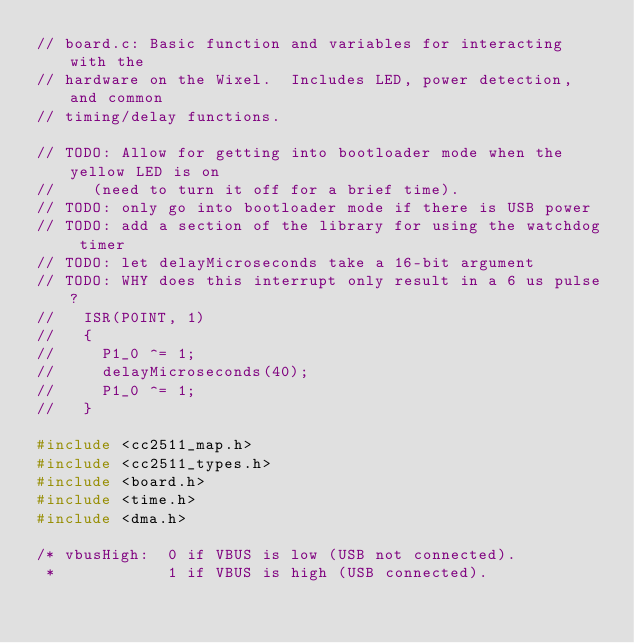<code> <loc_0><loc_0><loc_500><loc_500><_C_>// board.c: Basic function and variables for interacting with the
// hardware on the Wixel.  Includes LED, power detection, and common
// timing/delay functions.

// TODO: Allow for getting into bootloader mode when the yellow LED is on
//    (need to turn it off for a brief time).
// TODO: only go into bootloader mode if there is USB power
// TODO: add a section of the library for using the watchdog timer
// TODO: let delayMicroseconds take a 16-bit argument
// TODO: WHY does this interrupt only result in a 6 us pulse?
//   ISR(P0INT, 1)
//   {
//     P1_0 ^= 1;
//     delayMicroseconds(40);
//     P1_0 ^= 1;
//   }

#include <cc2511_map.h>
#include <cc2511_types.h>
#include <board.h>
#include <time.h>
#include <dma.h>

/* vbusHigh:  0 if VBUS is low (USB not connected).
 *            1 if VBUS is high (USB connected).</code> 